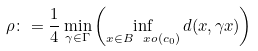Convert formula to latex. <formula><loc_0><loc_0><loc_500><loc_500>\rho \colon = \frac { 1 } { 4 } \min _ { \gamma \in \Gamma } \left ( \inf _ { x \in B _ { \ } x o ( c _ { 0 } ) } d ( x , \gamma x ) \right ) \,</formula> 